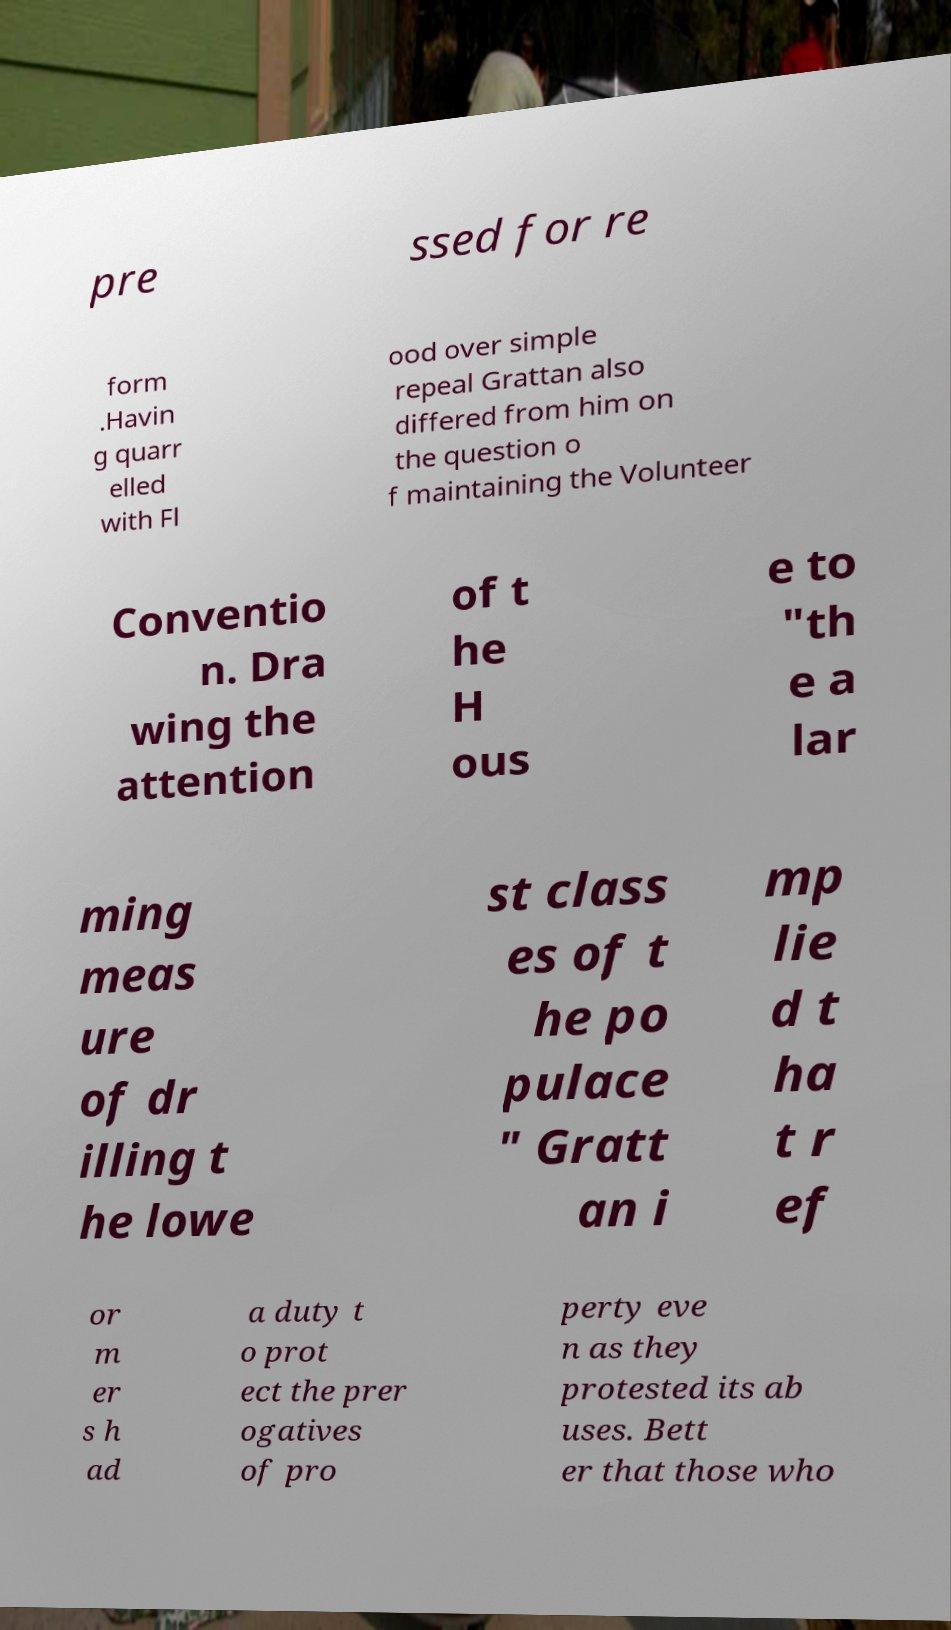Could you extract and type out the text from this image? pre ssed for re form .Havin g quarr elled with Fl ood over simple repeal Grattan also differed from him on the question o f maintaining the Volunteer Conventio n. Dra wing the attention of t he H ous e to "th e a lar ming meas ure of dr illing t he lowe st class es of t he po pulace " Gratt an i mp lie d t ha t r ef or m er s h ad a duty t o prot ect the prer ogatives of pro perty eve n as they protested its ab uses. Bett er that those who 